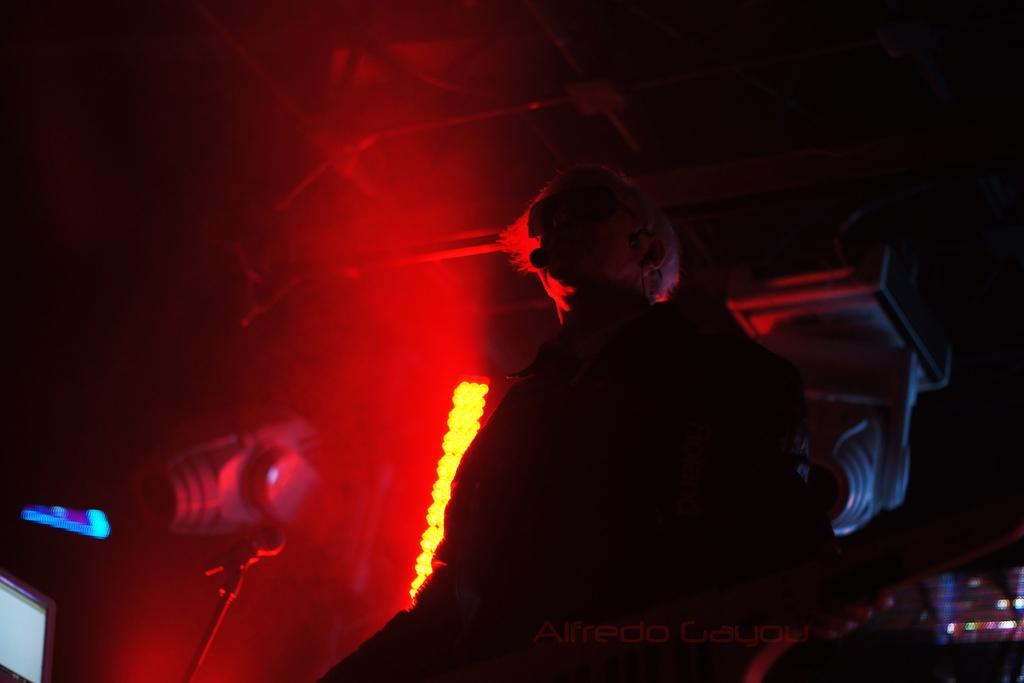Who or what is the main subject in the center of the image? There is a person in the center of the image. What object is located on the left side of the image? There is a microphone (mic) on the left side of the image. Can you describe the background of the image? There is a light in the background of the image. What type of ball can be seen bouncing in the image? There is no ball present in the image. What kind of lamp is illuminating the person in the image? The provided facts do not mention a lamp; only a light in the background is mentioned. 